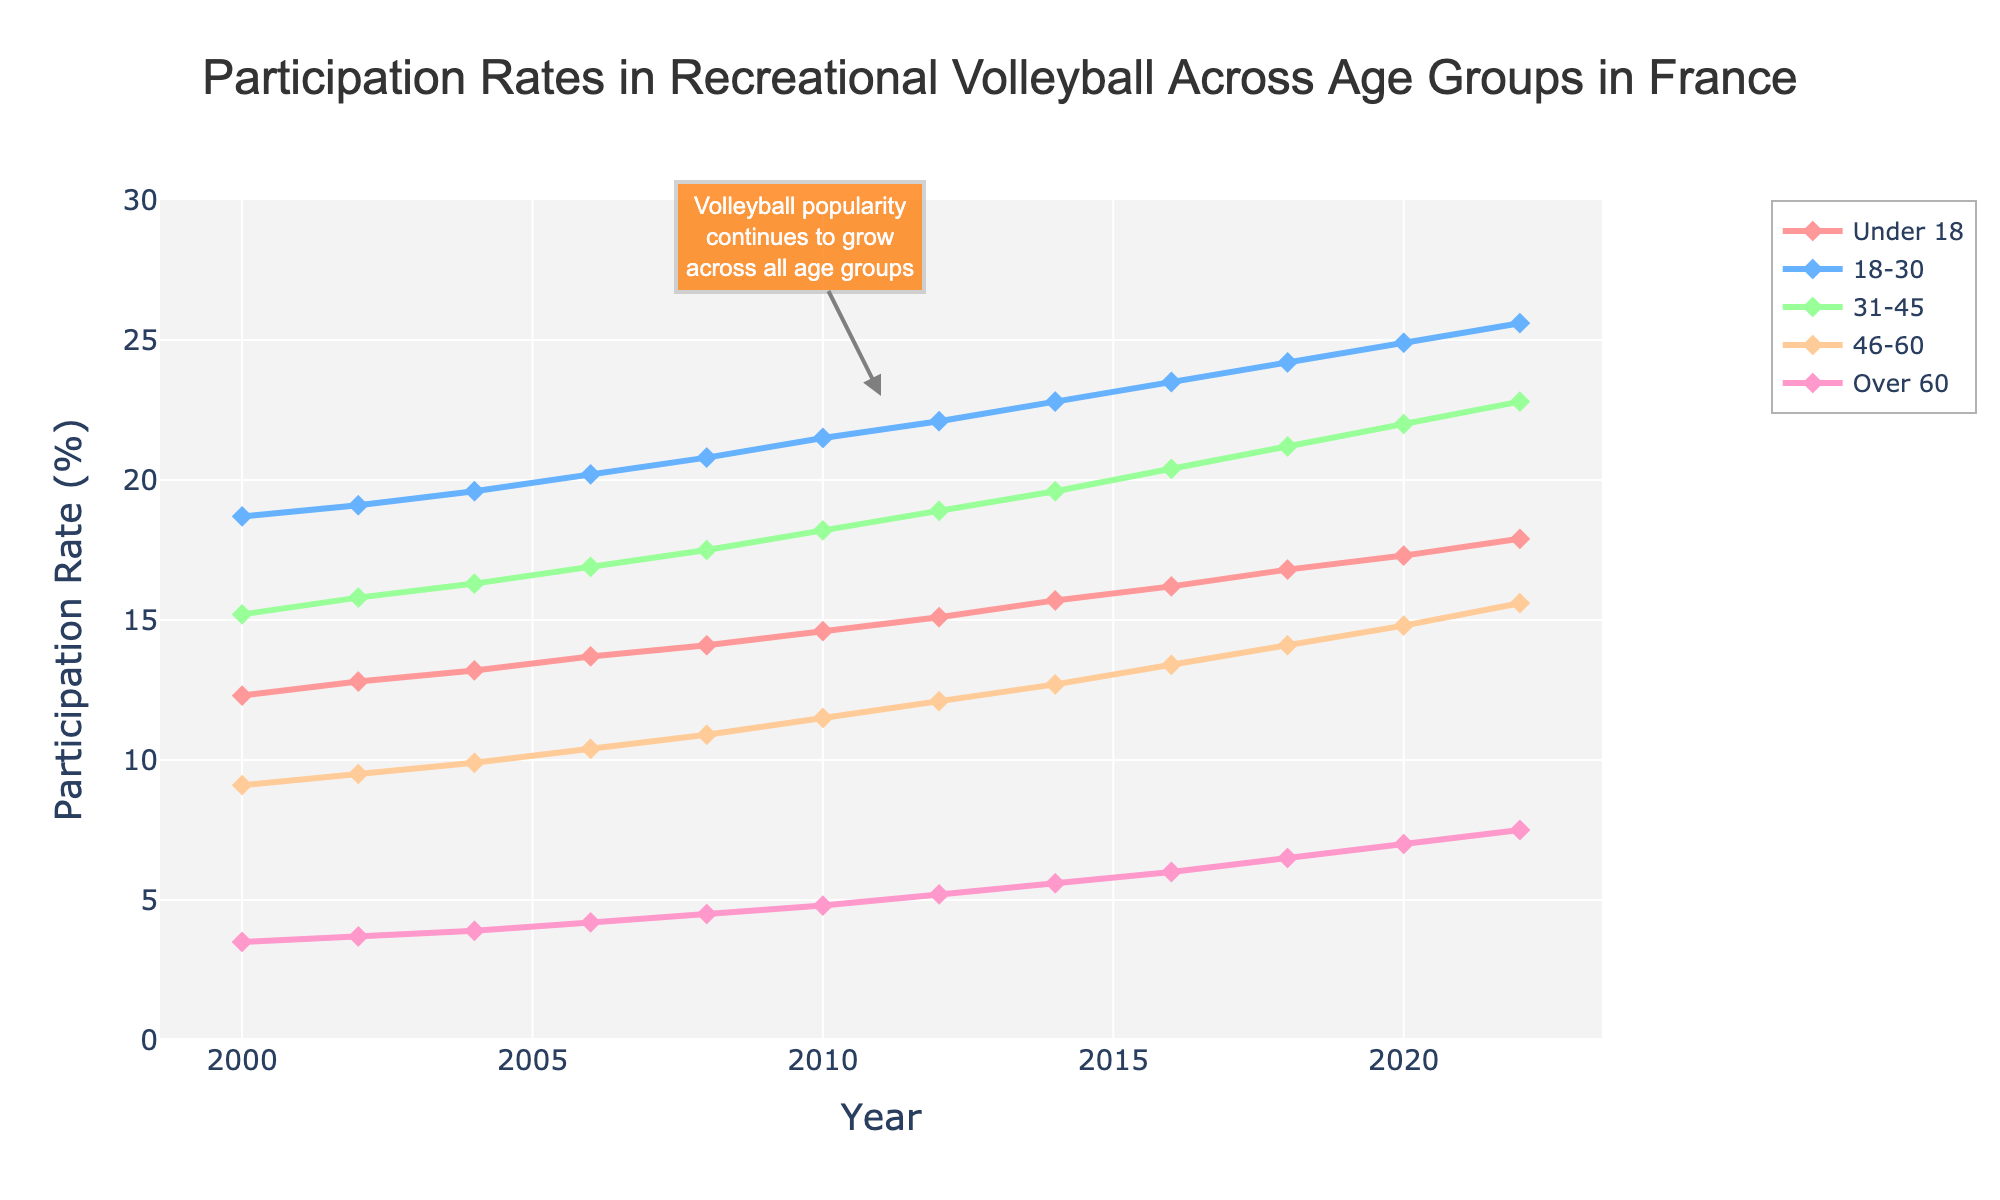what was the participation rate in the 18-30 age group in 2010? Look at the line corresponding to the 18-30 age group and find the y-axis value for the year 2010. The line is marked with specific colors for age groups.
Answer: 21.5% which age group saw the largest increase in participation rates from 2000 to 2022? Subtract the participation rates in 2000 from the rates in 2022 for all groups and compare the differences: 
- Under 18: 17.9 - 12.3 = 5.6
- 18-30: 25.6 - 18.7 = 6.9
- 31-45: 22.8 - 15.2 = 7.6
- 46-60: 15.6 - 9.1 = 6.5
- Over 60: 7.5 - 3.5 = 4.0.
The 31-45 group has the largest increase (7.6)
Answer: 31-45 which age group consistently has the lowest participation rate? Identify the line that remains the lowest in position from 2000 to 2022; this visual inspection helps determine the age group with the lowest participation.
Answer: Over 60 among the age groups, which one shows a participation rate closest to 20% by 2020? Look for the age group line that is closest to the 20% mark on the y-axis in the year 2020. The closest value by visual approximation is for the 31-45 age group.
Answer: 31-45 what is the total increase in participation rates for the 46-60 age group from 2000 to 2012? Calculate the difference between the rates in 2000 and 2012 for the 46-60 age group: 12.1 - 9.1 = 3.0.
Answer: 3.0 Which age group had approximately similar participation rates spanning 2010-2012? Compare the lines visually for the years 2010 and 2012 to identify which two data points are closest to each other within that time frame. The 18-30 age group is approximately similar between 2010 and 2012, both around 21.5% and 22.1%.
Answer: 18-30 how much did the participation rate of the Over 60 age group change from 2008 to 2022? Subtract the 2008 participation rate from the 2022 rate for the Over 60 age group: 7.5 - 4.5 = 3.0.
Answer: 3.0 is the Under 18 group participation rate increasing steadily over the years, and what was the rate in 2022? Look at the trend line for the Under 18 group from 2000 to 2022. The line should demonstrate an upward trend without any dips. The participation rate in 2022 is at the end of the line for the Under 18 group, which is around 17.9%.
Answer: Yes, it's increasing steadily. 17.9% which age group shows the slowest growth in participation rates over the years? Analyze the steepness of the lines; the age group with the least steep line has the slowest growth. The Over 60 age group’s line is least steep compared to others.
Answer: Over 60 